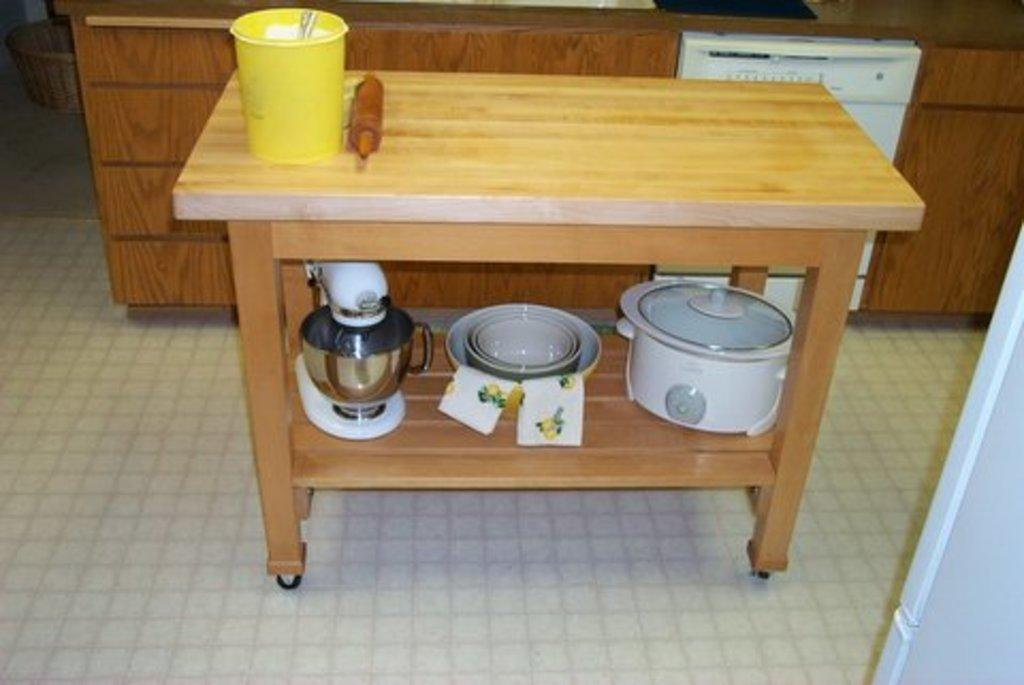What type of furniture is present in the image? There is a table in the image. What items can be found on the table? There are utensils, bowls, a rice cooker, and a plastic bucket on the table. What is the wooden object behind the table? There is a wooden object behind the table, but its specific purpose or type is not mentioned in the facts. What type of items related to cooking or serving food are visible in the image? Kitchen wear is visible in the image. What type of light can be seen illuminating the park in the image? There is no park or light present in the image; it features a table with various items on it and a wooden object behind the table. What type of badge is being worn by the person in the image? There is no person or badge present in the image. 